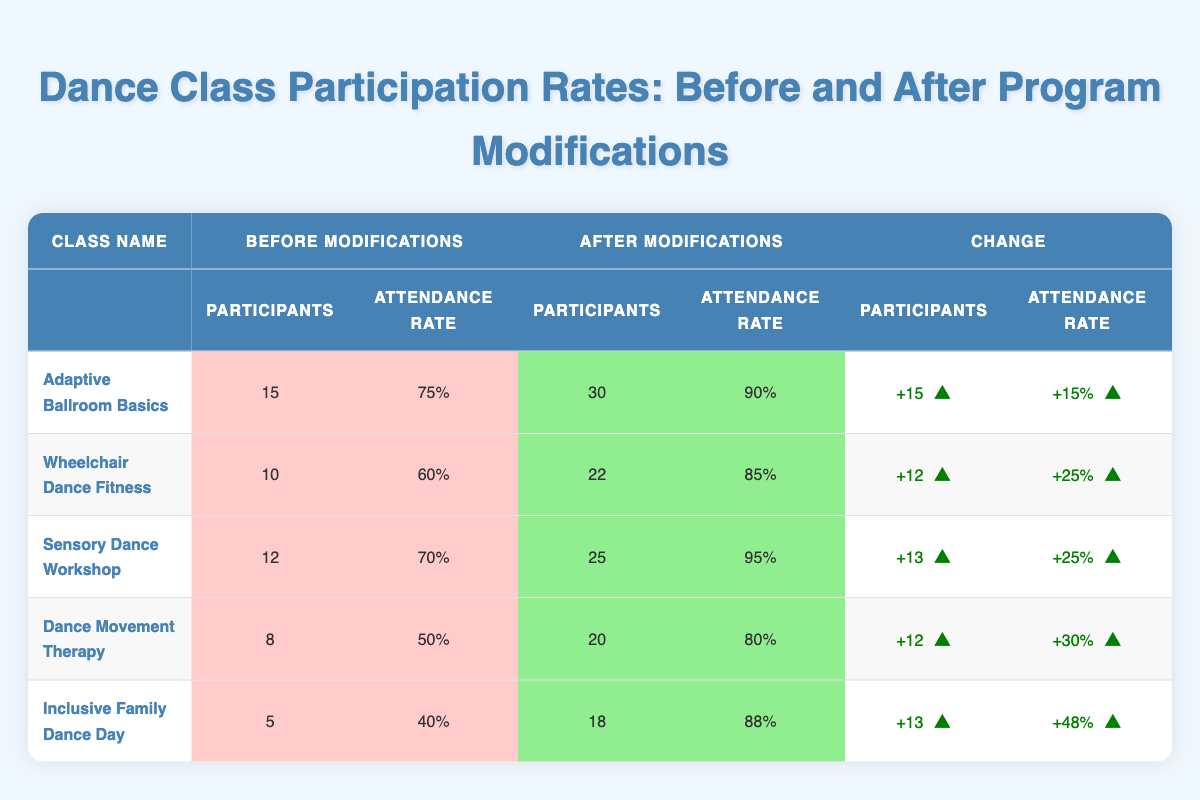What was the attendance rate for the "Wheelchair Dance Fitness" class before modifications? The table shows that the attendance rate for the "Wheelchair Dance Fitness" class before modifications was listed as 60%.
Answer: 60% How many participants attended the "Dance Movement Therapy" class after the modifications? According to the table, the number of participants for the "Dance Movement Therapy" class after modifications was listed as 20.
Answer: 20 Which class had the highest increase in attendance rate after modifications? By examining the attendance rates after modifications: "Inclusive Family Dance Day" had 88%, "Dance Movement Therapy" had 80%, "Adaptive Ballroom Basics" had 90%, "Sensory Dance Workshop" had 95%, and "Wheelchair Dance Fitness" had 85%. Hence, "Inclusive Family Dance Day" had the highest increase from 40% to 88%.
Answer: Inclusive Family Dance Day What is the total number of participants across all classes before modifications? The total participants before modifications can be calculated by summing the participants of each class: 15 + 10 + 12 + 8 + 5 = 50.
Answer: 50 Did any class see a decrease in attendance rate after modifications? Reviewing each class's attendance rates before and after modifications shows that all classes increased their attendance rates, so no class saw a decrease.
Answer: No What is the percentage increase in participants for the "Adaptive Ballroom Basics" class? The increase in participants was from 15 to 30, which is calculated as 30 - 15 = 15. The percentage increase is (15/15) * 100% = 100%.
Answer: 100% Which class had the lowest attendance rate after modifications? Looking at the attendance rates after modifications, "Dance Movement Therapy" had the lowest rate at 80%.
Answer: Dance Movement Therapy Calculate the average attendance rate after modifications across all classes. The attendance rates after modifications are 90%, 85%, 95%, 80%, and 88%, which sum to 90 + 85 + 95 + 80 + 88 = 438. The average is 438/5 = 87.6%.
Answer: 87.6% 